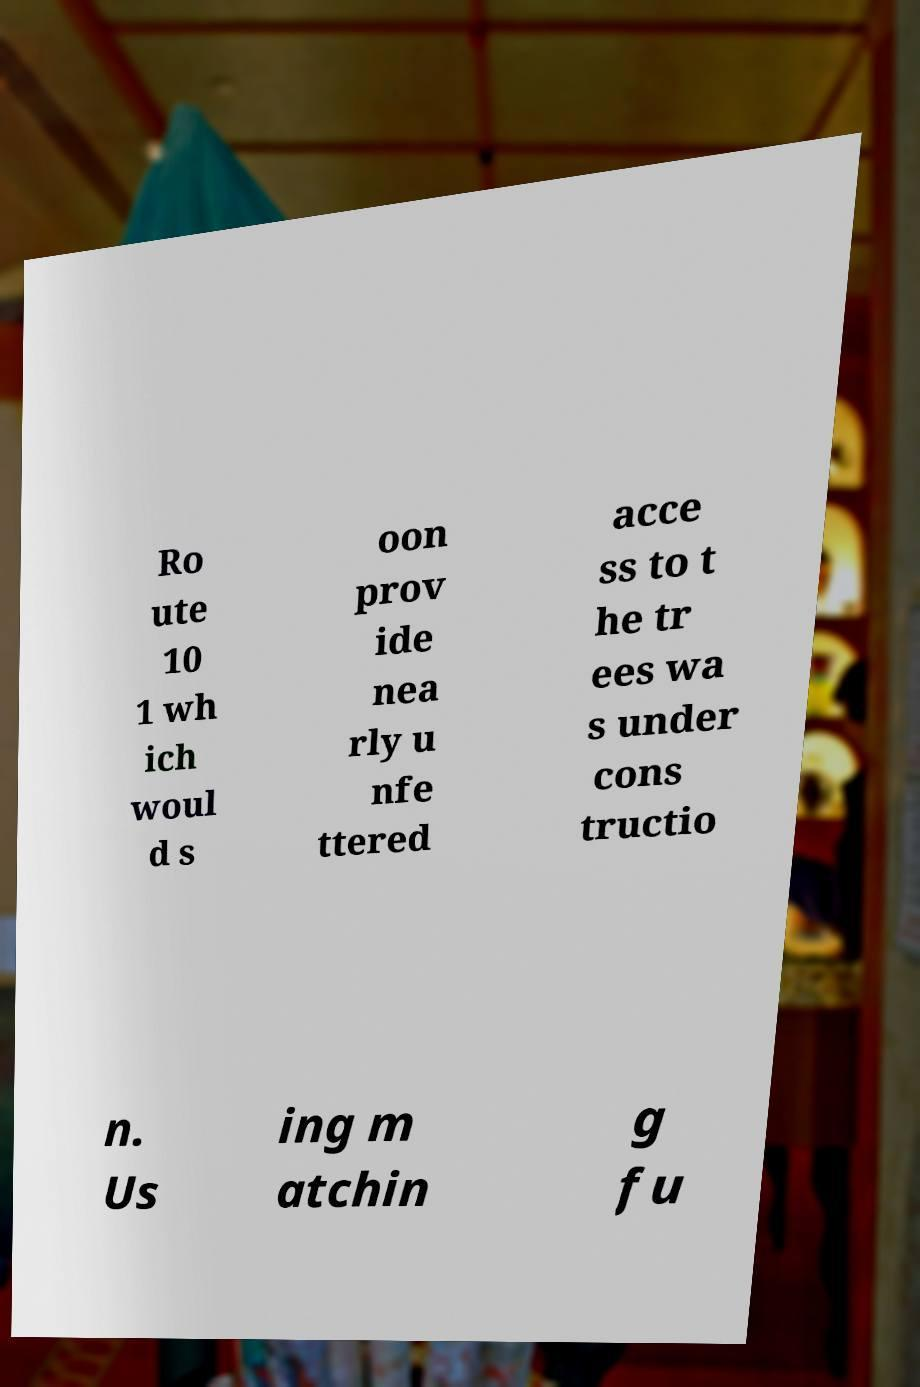Please identify and transcribe the text found in this image. Ro ute 10 1 wh ich woul d s oon prov ide nea rly u nfe ttered acce ss to t he tr ees wa s under cons tructio n. Us ing m atchin g fu 